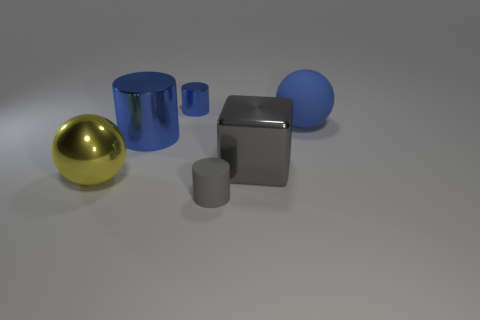Is the shiny block the same color as the small matte object?
Ensure brevity in your answer.  Yes. What size is the other cylinder that is the same color as the big metallic cylinder?
Give a very brief answer. Small. How many things are either blue things to the right of the matte cylinder or tiny blue metallic cylinders?
Provide a short and direct response. 2. What shape is the rubber thing that is the same color as the large cylinder?
Make the answer very short. Sphere. There is a tiny thing behind the ball on the left side of the block; what is it made of?
Your answer should be compact. Metal. Are there any small objects made of the same material as the large blue sphere?
Your response must be concise. Yes. Is there a thing in front of the blue metal cylinder that is behind the big matte object?
Make the answer very short. Yes. There is a large ball that is behind the big blue shiny thing; what material is it?
Give a very brief answer. Rubber. Is the gray rubber thing the same shape as the small blue object?
Your answer should be very brief. Yes. There is a object in front of the big shiny ball left of the blue cylinder that is in front of the small metallic cylinder; what is its color?
Offer a terse response. Gray. 